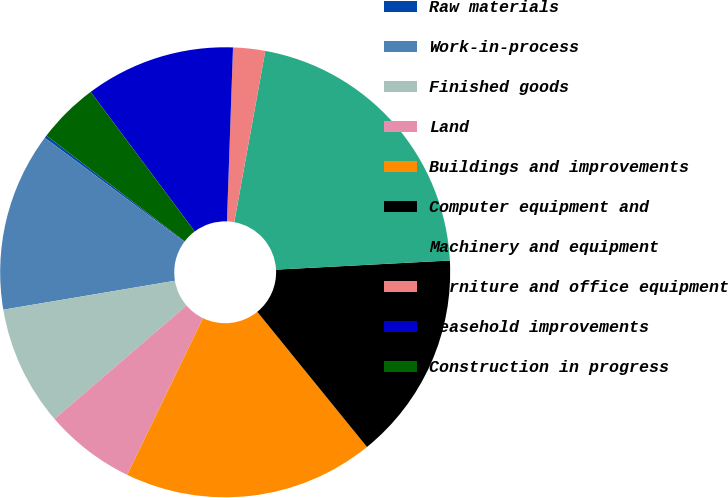<chart> <loc_0><loc_0><loc_500><loc_500><pie_chart><fcel>Raw materials<fcel>Work-in-process<fcel>Finished goods<fcel>Land<fcel>Buildings and improvements<fcel>Computer equipment and<fcel>Machinery and equipment<fcel>Furniture and office equipment<fcel>Leasehold improvements<fcel>Construction in progress<nl><fcel>0.19%<fcel>12.86%<fcel>8.64%<fcel>6.53%<fcel>18.02%<fcel>14.98%<fcel>21.31%<fcel>2.3%<fcel>10.75%<fcel>4.41%<nl></chart> 